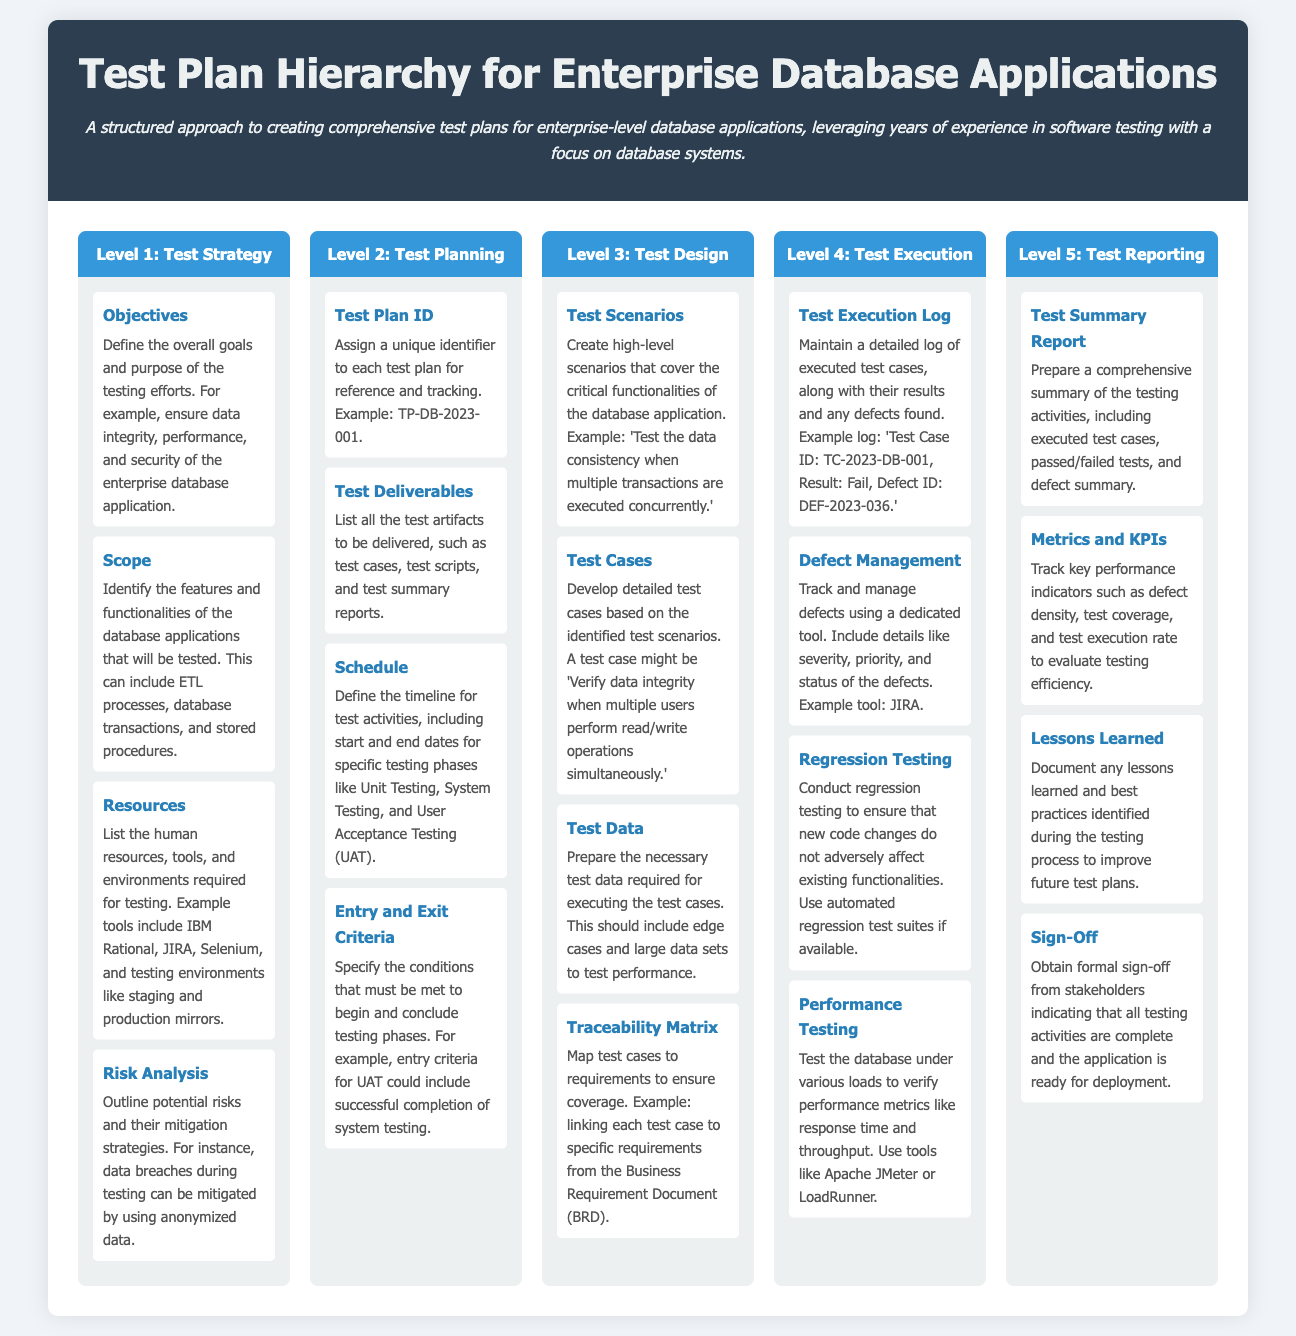What is the main title of the document? The main title is prominently displayed in the header section of the infographic.
Answer: Test Plan Hierarchy for Enterprise Database Applications What is the focus of the document? The description under the title summarizes the document's purpose and focus area.
Answer: Comprehensive test plans for enterprise-level database applications What level covers Test Strategy? Each level of the hierarchy is marked with a header, identifying its main topic.
Answer: Level 1: Test Strategy What is an example of a Test Plan ID? The document provides a specific example of how a Test Plan ID should be organized.
Answer: TP-DB-2023-001 What is mentioned under Risk Analysis? The details about Risk Analysis provide insights into this component's purpose within the strategy.
Answer: Outline potential risks and their mitigation strategies Which component discusses performance metrics? The Test Execution section includes a component dedicated to verifying performance metrics.
Answer: Performance Testing What should be prepared according to Test Reporting? The summary in the last section suggests a specific document to be prepared based on testing results.
Answer: Test Summary Report What is an example tool for defect management? One of the components provides an example tool that can be used for tracking defects.
Answer: JIRA Which component covers entry and exit conditions? This component is discussed within the Test Planning section addressing the specific conditions for testing phases.
Answer: Entry and Exit Criteria 